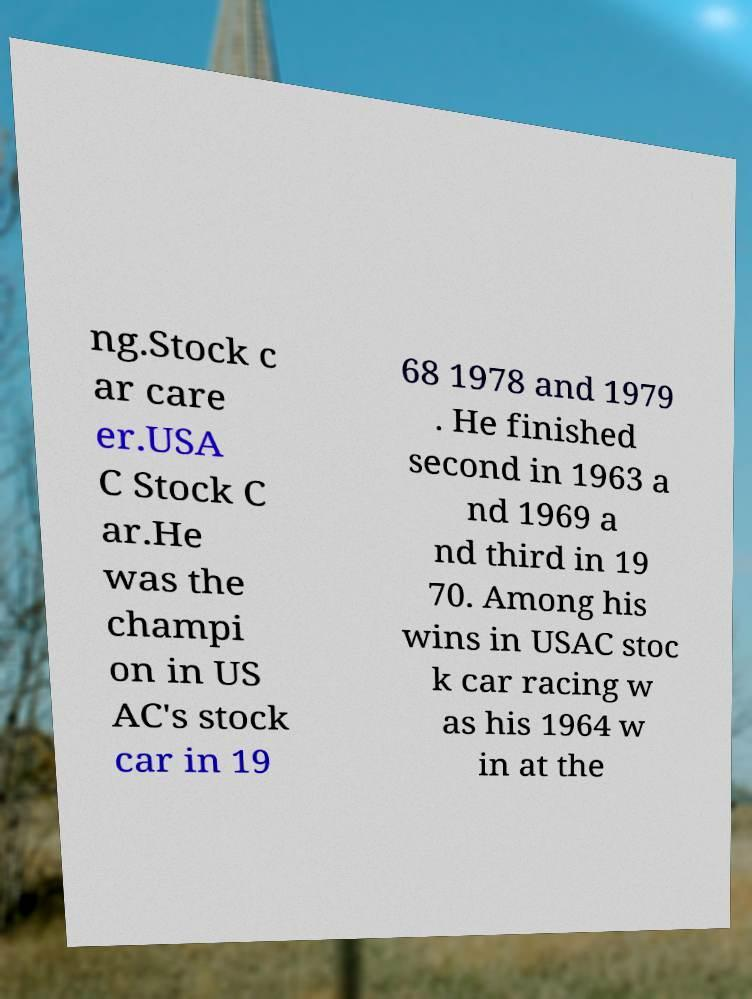Please identify and transcribe the text found in this image. ng.Stock c ar care er.USA C Stock C ar.He was the champi on in US AC's stock car in 19 68 1978 and 1979 . He finished second in 1963 a nd 1969 a nd third in 19 70. Among his wins in USAC stoc k car racing w as his 1964 w in at the 